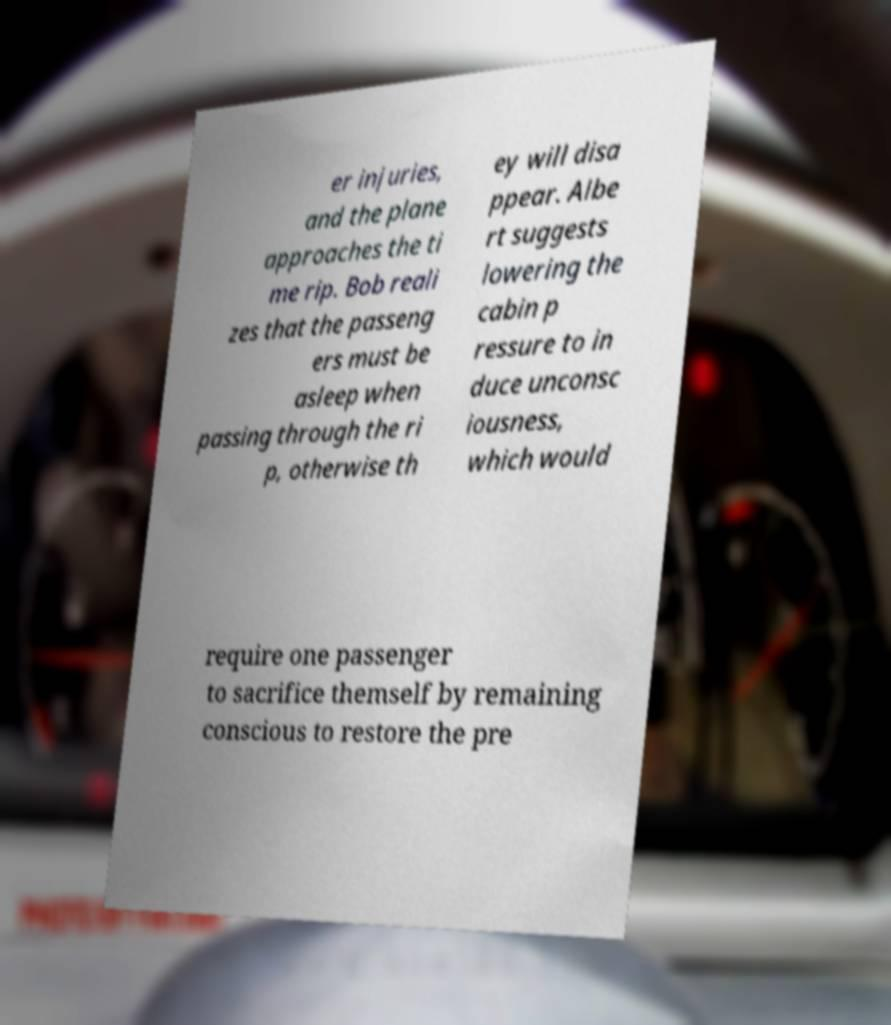Could you extract and type out the text from this image? er injuries, and the plane approaches the ti me rip. Bob reali zes that the passeng ers must be asleep when passing through the ri p, otherwise th ey will disa ppear. Albe rt suggests lowering the cabin p ressure to in duce unconsc iousness, which would require one passenger to sacrifice themself by remaining conscious to restore the pre 